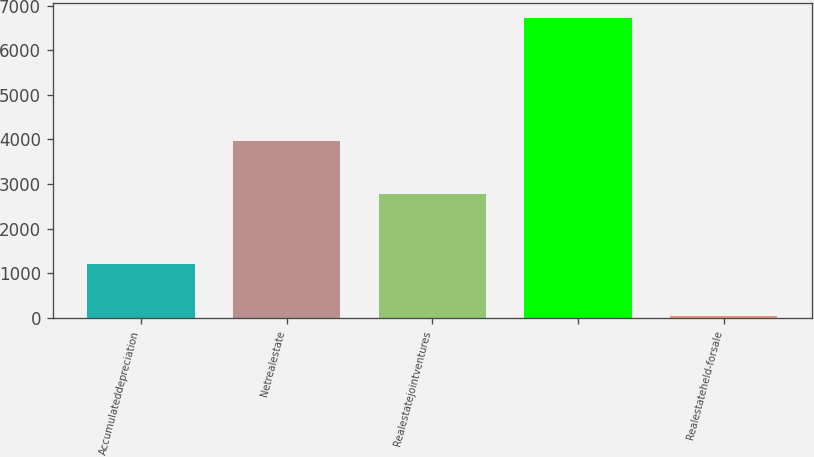Convert chart. <chart><loc_0><loc_0><loc_500><loc_500><bar_chart><fcel>Accumulateddepreciation<fcel>Netrealestate<fcel>Realestatejointventures<fcel>Unnamed: 3<fcel>Realestateheld-forsale<nl><fcel>1210<fcel>3957<fcel>2771<fcel>6728<fcel>39<nl></chart> 